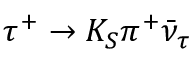<formula> <loc_0><loc_0><loc_500><loc_500>\tau ^ { + } \to K _ { S } \pi ^ { + } \bar { \nu } _ { \tau }</formula> 